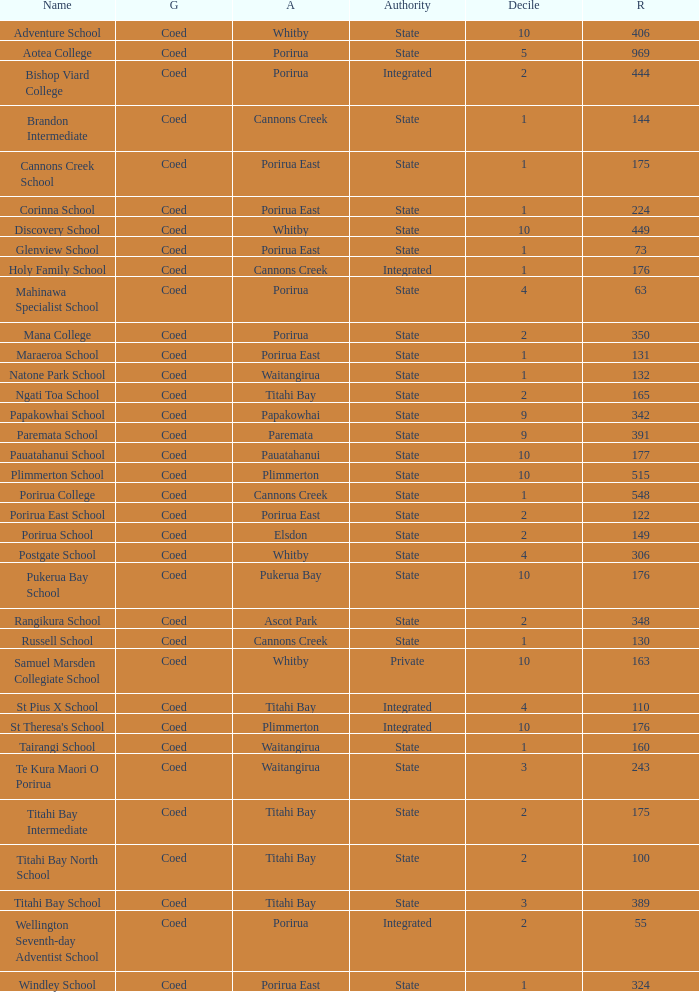What was the decile of Samuel Marsden Collegiate School in Whitby, when it had a roll higher than 163? 0.0. 